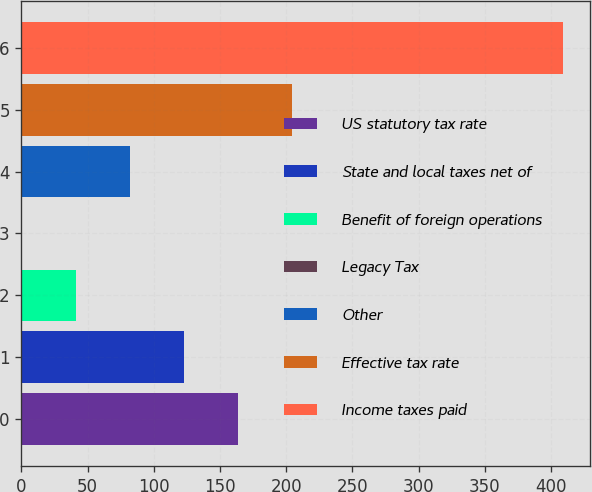Convert chart to OTSL. <chart><loc_0><loc_0><loc_500><loc_500><bar_chart><fcel>US statutory tax rate<fcel>State and local taxes net of<fcel>Benefit of foreign operations<fcel>Legacy Tax<fcel>Other<fcel>Effective tax rate<fcel>Income taxes paid<nl><fcel>163.58<fcel>122.71<fcel>40.97<fcel>0.1<fcel>81.84<fcel>204.45<fcel>408.8<nl></chart> 